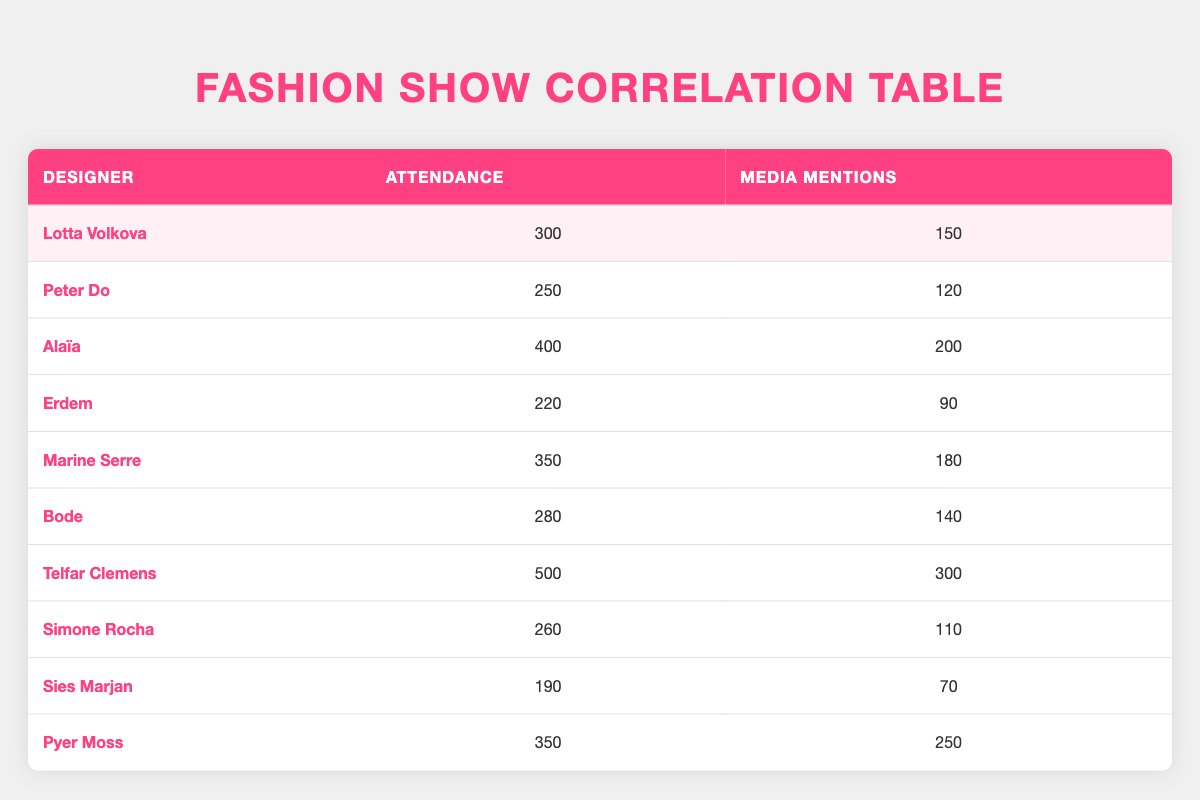What is the attendance for Lotta Volkova's fashion show? According to the table, Lotta Volkova's attendance is listed under the "Attendance" column as 300.
Answer: 300 Which designer had the highest media mentions? By examining the "Media Mentions" column, Telfar Clemens is noted with 300 media mentions, which is the highest compared to the others.
Answer: Telfar Clemens What is the total attendance of designers whose media mentions are greater than 200? The designers with media mentions greater than 200 are Alaïa (400) and Telfar Clemens (500). Summing their attendance gives: 400 + 500 = 900.
Answer: 900 Is Pyer Moss's attendance greater than Lotta Volkova's attendance? The attendance for Pyer Moss is 350, which is greater than Lotta Volkova's attendance of 300 as per the respective entries in the table.
Answer: Yes What is the difference in media mentions between the designer with the highest attendance and the designer with the lowest attendance? The designer with the highest attendance is Telfar Clemens (500) and the lowest is Sies Marjan (190). Their respective media mentions are 300 and 70. The difference is (300 - 70) = 230.
Answer: 230 Calculate the average attendance of all designers. The total attendance is calculated as (300 + 250 + 400 + 220 + 350 + 280 + 500 + 260 + 190 + 350) = 3000, and there are 10 designers, so the average is 3000 / 10 = 300.
Answer: 300 Are there any designers whose attendance is equal to their media mentions? When examining the data, there are no entries where the attendance matches the media mentions exactly. Each designer has different values for these two attributes.
Answer: No Which designer has the least media mentions, and what is the value? From the "Media Mentions" column, Sies Marjan has the least with 70 mentions, which can be directly noted from the table.
Answer: Sies Marjan; 70 What is the combined media mentions of designers with attendance less than 300? The designers with attendance less than 300 are Peter Do (120), Erdem (90), Simone Rocha (110), and Sies Marjan (70). Their combined media mentions are 120 + 90 + 110 + 70 = 390.
Answer: 390 